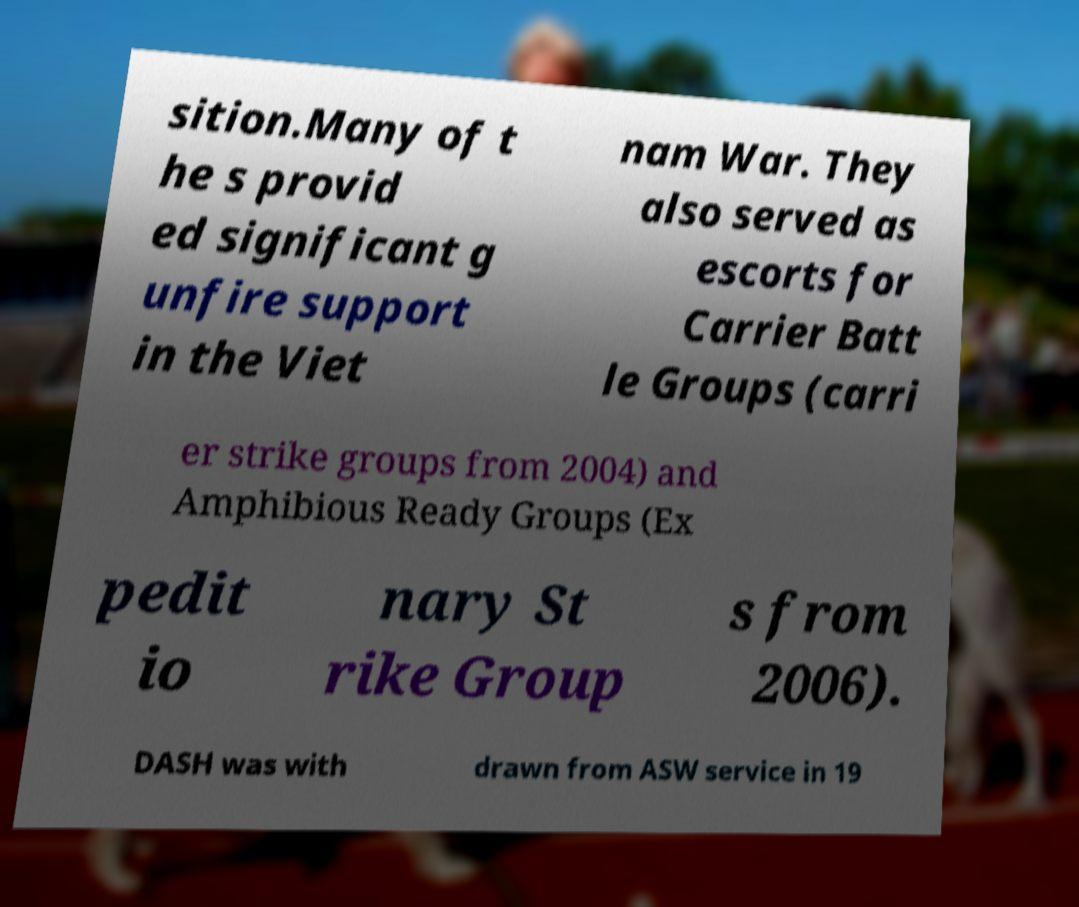For documentation purposes, I need the text within this image transcribed. Could you provide that? sition.Many of t he s provid ed significant g unfire support in the Viet nam War. They also served as escorts for Carrier Batt le Groups (carri er strike groups from 2004) and Amphibious Ready Groups (Ex pedit io nary St rike Group s from 2006). DASH was with drawn from ASW service in 19 